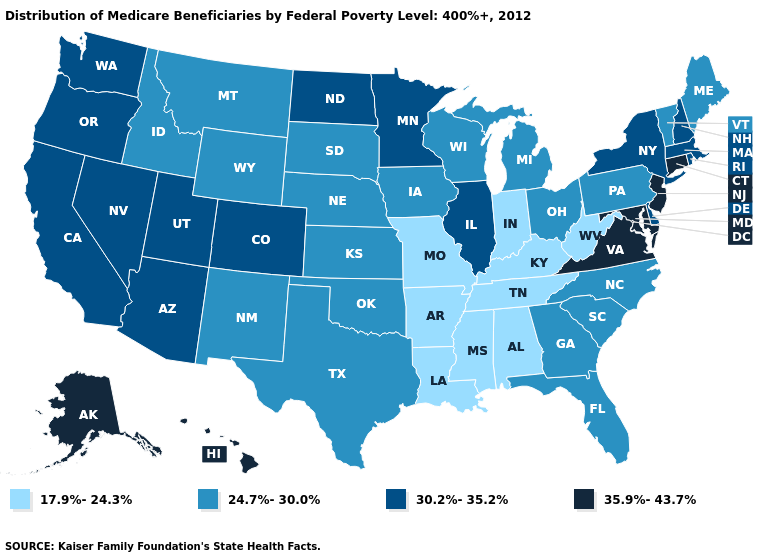What is the value of Connecticut?
Short answer required. 35.9%-43.7%. Does California have a higher value than New Jersey?
Write a very short answer. No. Name the states that have a value in the range 24.7%-30.0%?
Answer briefly. Florida, Georgia, Idaho, Iowa, Kansas, Maine, Michigan, Montana, Nebraska, New Mexico, North Carolina, Ohio, Oklahoma, Pennsylvania, South Carolina, South Dakota, Texas, Vermont, Wisconsin, Wyoming. Name the states that have a value in the range 30.2%-35.2%?
Answer briefly. Arizona, California, Colorado, Delaware, Illinois, Massachusetts, Minnesota, Nevada, New Hampshire, New York, North Dakota, Oregon, Rhode Island, Utah, Washington. Among the states that border Illinois , does Indiana have the lowest value?
Short answer required. Yes. Is the legend a continuous bar?
Write a very short answer. No. Which states have the lowest value in the South?
Be succinct. Alabama, Arkansas, Kentucky, Louisiana, Mississippi, Tennessee, West Virginia. Name the states that have a value in the range 24.7%-30.0%?
Write a very short answer. Florida, Georgia, Idaho, Iowa, Kansas, Maine, Michigan, Montana, Nebraska, New Mexico, North Carolina, Ohio, Oklahoma, Pennsylvania, South Carolina, South Dakota, Texas, Vermont, Wisconsin, Wyoming. What is the lowest value in states that border Pennsylvania?
Answer briefly. 17.9%-24.3%. Among the states that border New Hampshire , which have the lowest value?
Concise answer only. Maine, Vermont. Name the states that have a value in the range 17.9%-24.3%?
Write a very short answer. Alabama, Arkansas, Indiana, Kentucky, Louisiana, Mississippi, Missouri, Tennessee, West Virginia. What is the value of Oklahoma?
Give a very brief answer. 24.7%-30.0%. What is the highest value in the USA?
Write a very short answer. 35.9%-43.7%. What is the value of Tennessee?
Short answer required. 17.9%-24.3%. Name the states that have a value in the range 30.2%-35.2%?
Concise answer only. Arizona, California, Colorado, Delaware, Illinois, Massachusetts, Minnesota, Nevada, New Hampshire, New York, North Dakota, Oregon, Rhode Island, Utah, Washington. 